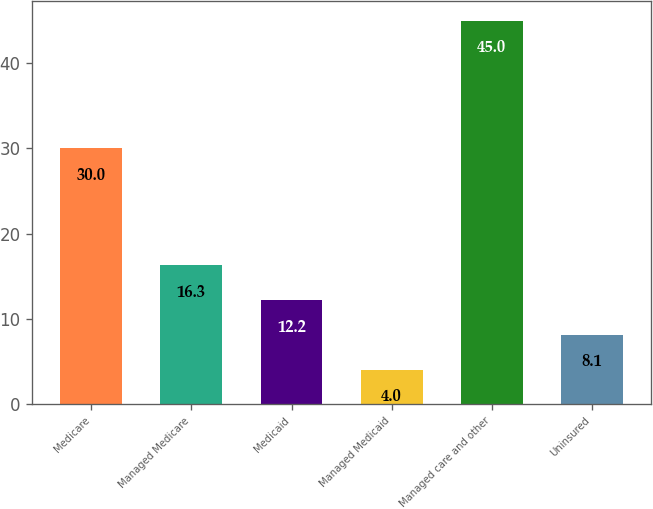<chart> <loc_0><loc_0><loc_500><loc_500><bar_chart><fcel>Medicare<fcel>Managed Medicare<fcel>Medicaid<fcel>Managed Medicaid<fcel>Managed care and other<fcel>Uninsured<nl><fcel>30<fcel>16.3<fcel>12.2<fcel>4<fcel>45<fcel>8.1<nl></chart> 